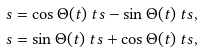<formula> <loc_0><loc_0><loc_500><loc_500>\ s & = \cos \Theta ( t ) \ t s - \sin \Theta ( t ) \ t s , \\ \ s & = \sin \Theta ( t ) \ t s + \cos \Theta ( t ) \ t s ,</formula> 